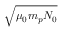Convert formula to latex. <formula><loc_0><loc_0><loc_500><loc_500>\sqrt { \mu _ { 0 } m _ { p } N _ { 0 } }</formula> 